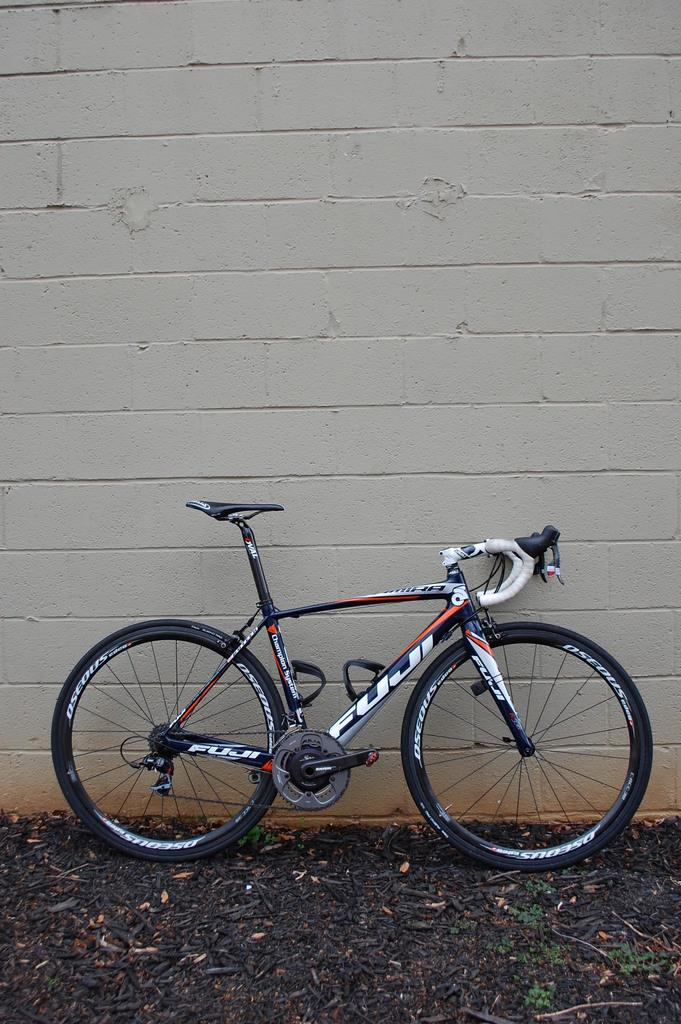What is the main object in the image? There is a bicycle in the image. What can be seen in the background of the image? There is a wall in the image. What type of surface is visible in the image? Soil is present in the image. Are there any fairies visible in the image? There are no fairies present in the image. What does the farmer believe about the bicycle in the image? There is no farmer present in the image, and therefore no belief about the bicycle can be determined. 